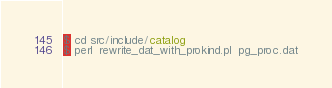Convert code to text. <code><loc_0><loc_0><loc_500><loc_500><_SQL_>$ cd src/include/catalog
$ perl  rewrite_dat_with_prokind.pl  pg_proc.dat
</code> 